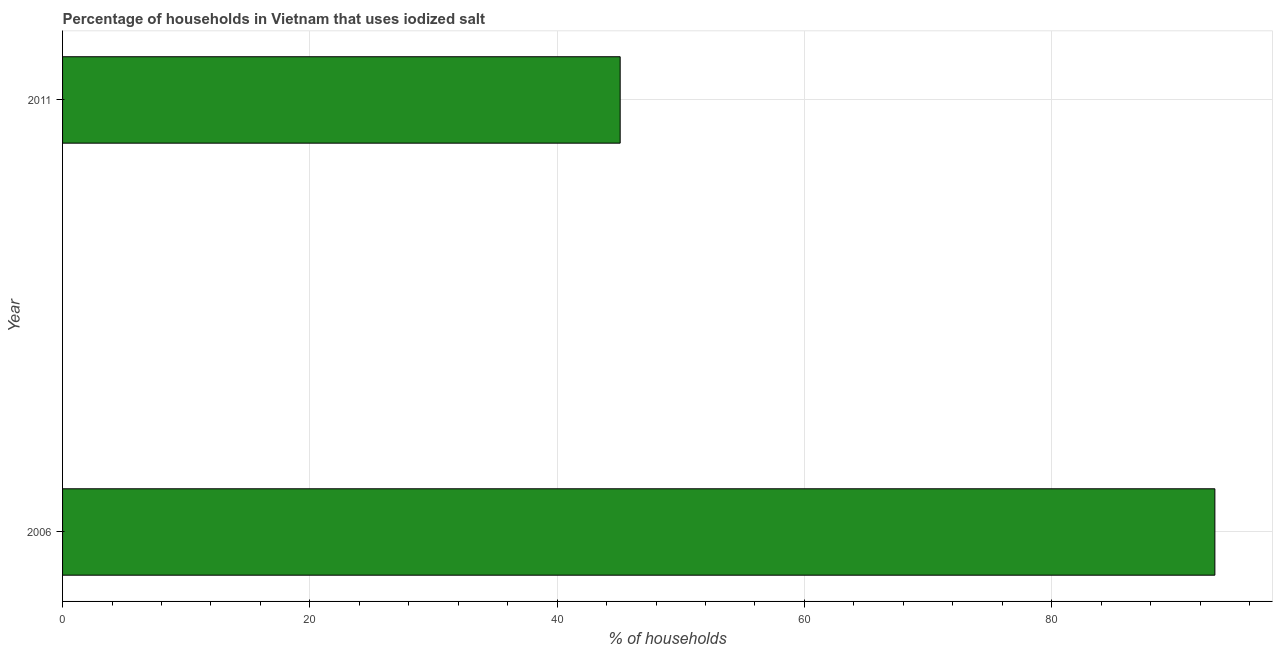Does the graph contain grids?
Offer a terse response. Yes. What is the title of the graph?
Ensure brevity in your answer.  Percentage of households in Vietnam that uses iodized salt. What is the label or title of the X-axis?
Your answer should be very brief. % of households. What is the label or title of the Y-axis?
Provide a short and direct response. Year. What is the percentage of households where iodized salt is consumed in 2006?
Your response must be concise. 93.2. Across all years, what is the maximum percentage of households where iodized salt is consumed?
Provide a short and direct response. 93.2. Across all years, what is the minimum percentage of households where iodized salt is consumed?
Your response must be concise. 45.1. In which year was the percentage of households where iodized salt is consumed minimum?
Offer a very short reply. 2011. What is the sum of the percentage of households where iodized salt is consumed?
Provide a succinct answer. 138.3. What is the difference between the percentage of households where iodized salt is consumed in 2006 and 2011?
Your answer should be compact. 48.1. What is the average percentage of households where iodized salt is consumed per year?
Your answer should be compact. 69.15. What is the median percentage of households where iodized salt is consumed?
Your answer should be very brief. 69.15. What is the ratio of the percentage of households where iodized salt is consumed in 2006 to that in 2011?
Provide a short and direct response. 2.07. Is the percentage of households where iodized salt is consumed in 2006 less than that in 2011?
Your answer should be very brief. No. How many bars are there?
Make the answer very short. 2. How many years are there in the graph?
Your response must be concise. 2. What is the difference between two consecutive major ticks on the X-axis?
Your answer should be very brief. 20. Are the values on the major ticks of X-axis written in scientific E-notation?
Offer a terse response. No. What is the % of households in 2006?
Provide a succinct answer. 93.2. What is the % of households of 2011?
Give a very brief answer. 45.1. What is the difference between the % of households in 2006 and 2011?
Keep it short and to the point. 48.1. What is the ratio of the % of households in 2006 to that in 2011?
Your answer should be compact. 2.07. 